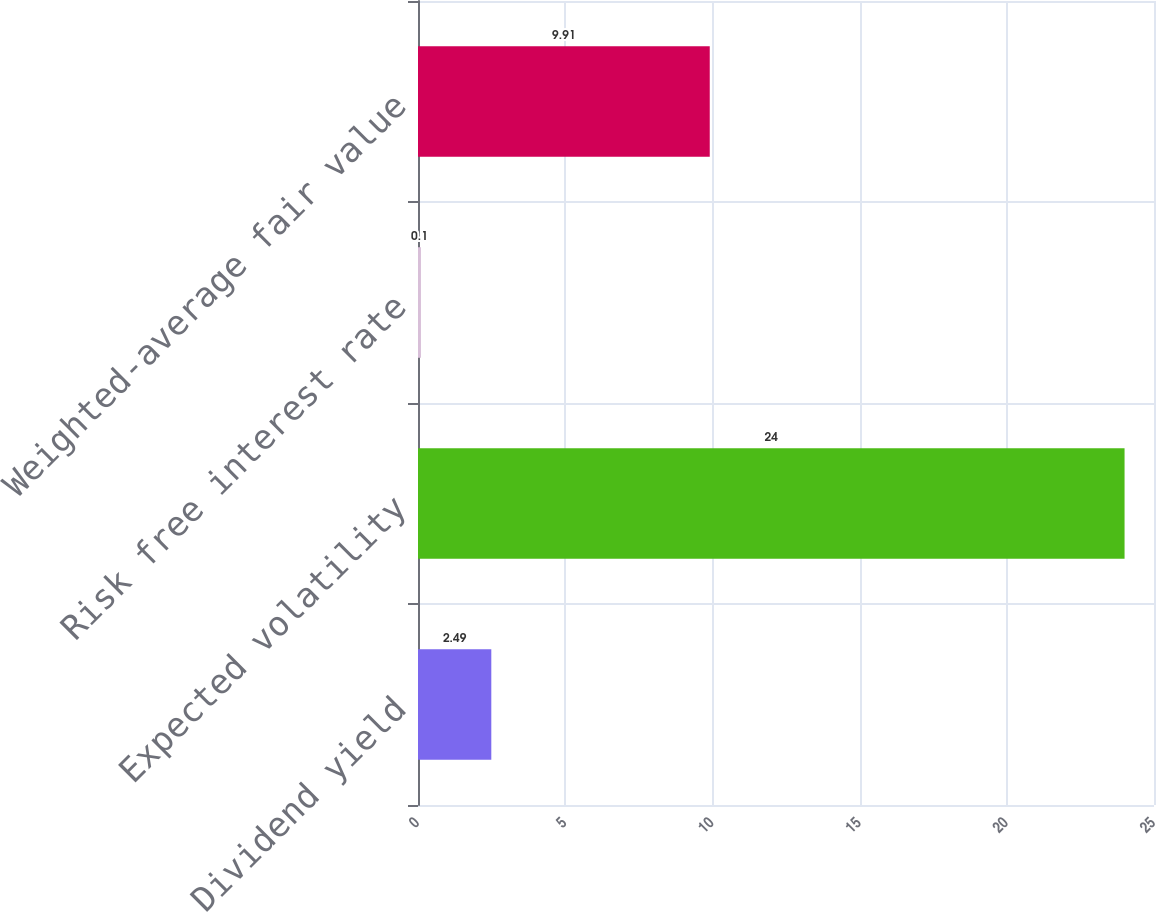<chart> <loc_0><loc_0><loc_500><loc_500><bar_chart><fcel>Dividend yield<fcel>Expected volatility<fcel>Risk free interest rate<fcel>Weighted-average fair value<nl><fcel>2.49<fcel>24<fcel>0.1<fcel>9.91<nl></chart> 